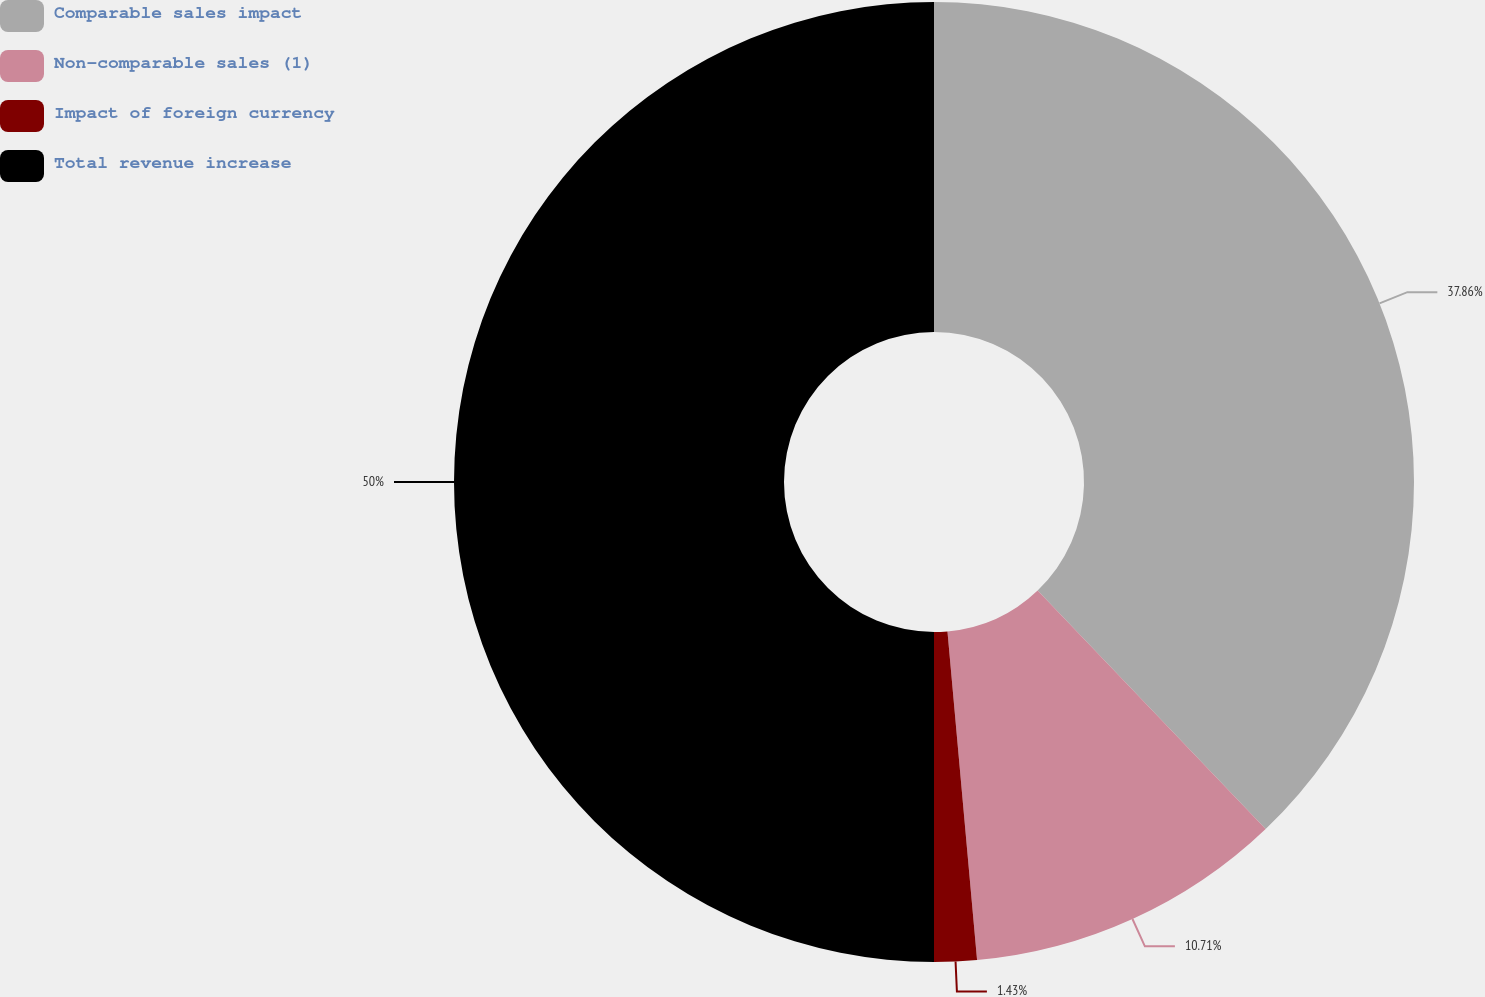Convert chart. <chart><loc_0><loc_0><loc_500><loc_500><pie_chart><fcel>Comparable sales impact<fcel>Non-comparable sales (1)<fcel>Impact of foreign currency<fcel>Total revenue increase<nl><fcel>37.86%<fcel>10.71%<fcel>1.43%<fcel>50.0%<nl></chart> 